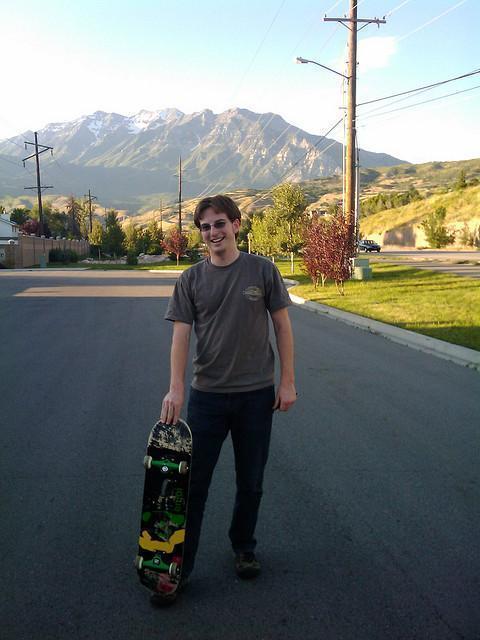What setting does the boarder pose in here?
Choose the right answer and clarify with the format: 'Answer: answer
Rationale: rationale.'
Options: Urban, suburban, desert, farm. Answer: suburban.
Rationale: The boarder is posing on a street in the suburbs. 